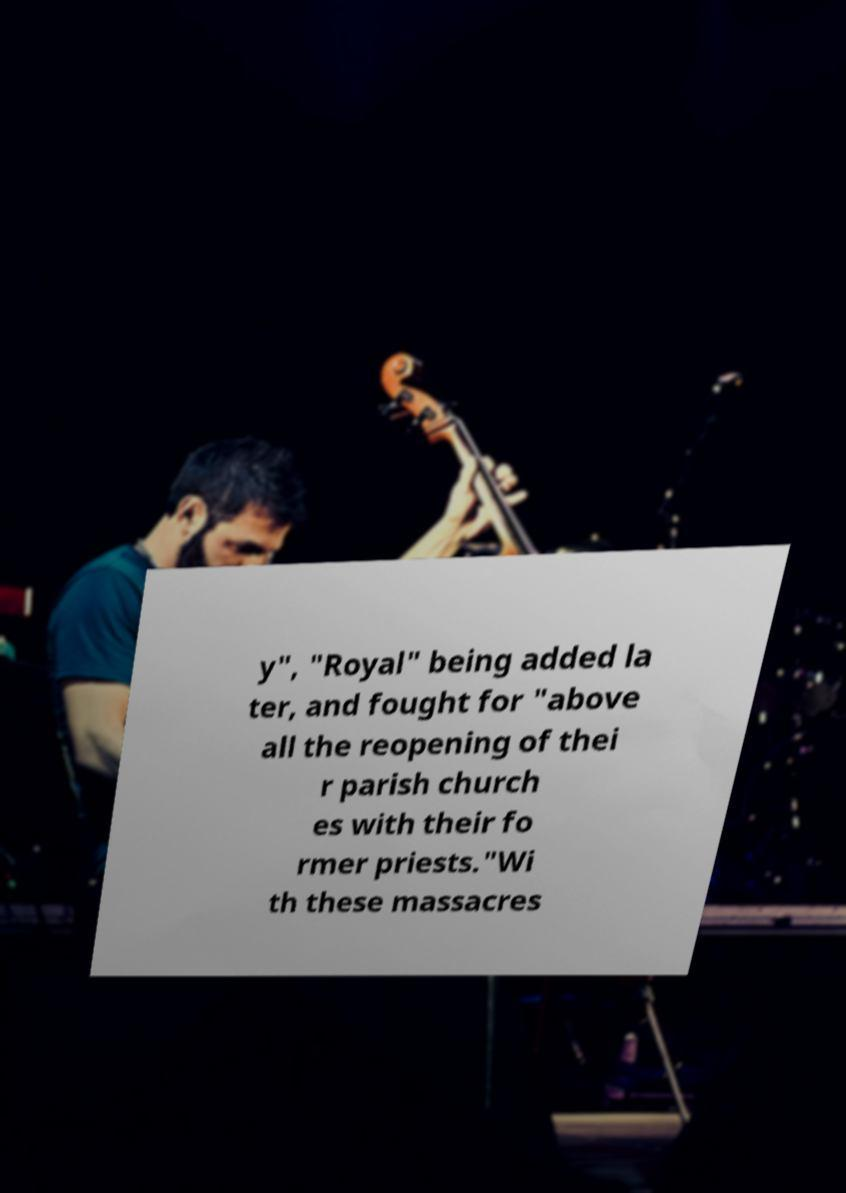What messages or text are displayed in this image? I need them in a readable, typed format. y", "Royal" being added la ter, and fought for "above all the reopening of thei r parish church es with their fo rmer priests."Wi th these massacres 